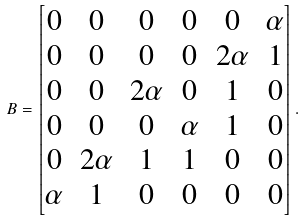Convert formula to latex. <formula><loc_0><loc_0><loc_500><loc_500>B = \begin{bmatrix} 0 & 0 & 0 & 0 & 0 & \alpha \\ 0 & 0 & 0 & 0 & 2 \alpha & 1 \\ 0 & 0 & 2 \alpha & 0 & 1 & 0 \\ 0 & 0 & 0 & \alpha & 1 & 0 \\ 0 & 2 \alpha & 1 & 1 & 0 & 0 \\ \alpha & 1 & 0 & 0 & 0 & 0 \end{bmatrix} .</formula> 